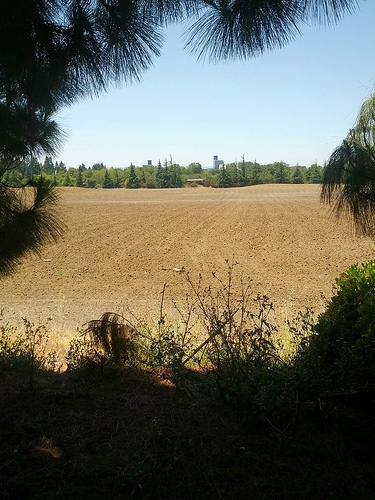<image>
Is there a sky behind the trees? Yes. From this viewpoint, the sky is positioned behind the trees, with the trees partially or fully occluding the sky. 